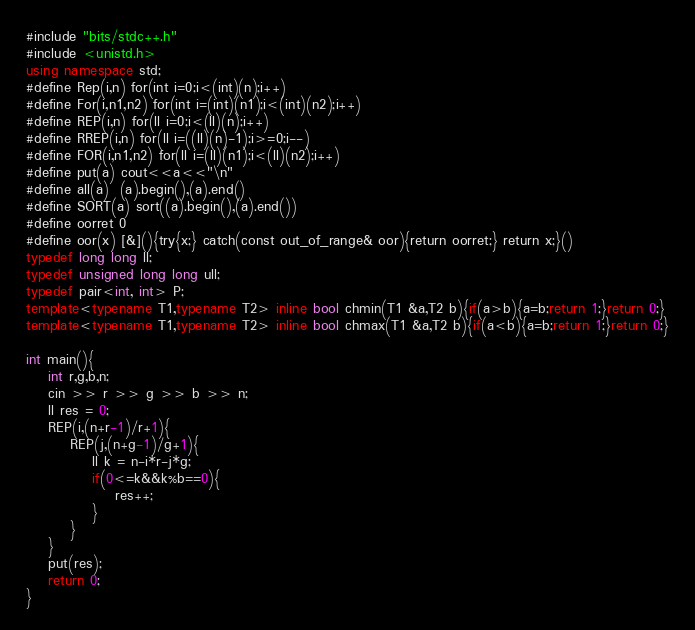<code> <loc_0><loc_0><loc_500><loc_500><_C++_>#include "bits/stdc++.h"
#include <unistd.h>
using namespace std;
#define Rep(i,n) for(int i=0;i<(int)(n);i++)
#define For(i,n1,n2) for(int i=(int)(n1);i<(int)(n2);i++)
#define REP(i,n) for(ll i=0;i<(ll)(n);i++)
#define RREP(i,n) for(ll i=((ll)(n)-1);i>=0;i--)
#define FOR(i,n1,n2) for(ll i=(ll)(n1);i<(ll)(n2);i++)
#define put(a) cout<<a<<"\n"
#define all(a)  (a).begin(),(a).end()
#define SORT(a) sort((a).begin(),(a).end())
#define oorret 0
#define oor(x) [&](){try{x;} catch(const out_of_range& oor){return oorret;} return x;}()
typedef long long ll;
typedef unsigned long long ull;
typedef pair<int, int> P;
template<typename T1,typename T2> inline bool chmin(T1 &a,T2 b){if(a>b){a=b;return 1;}return 0;}
template<typename T1,typename T2> inline bool chmax(T1 &a,T2 b){if(a<b){a=b;return 1;}return 0;}

int main(){
    int r,g,b,n;
    cin >> r >> g >> b >> n;
    ll res = 0;
    REP(i,(n+r-1)/r+1){
        REP(j,(n+g-1)/g+1){
            ll k = n-i*r-j*g;
            if(0<=k&&k%b==0){
                res++;
            }
        }
    }
    put(res);
    return 0;
}
</code> 